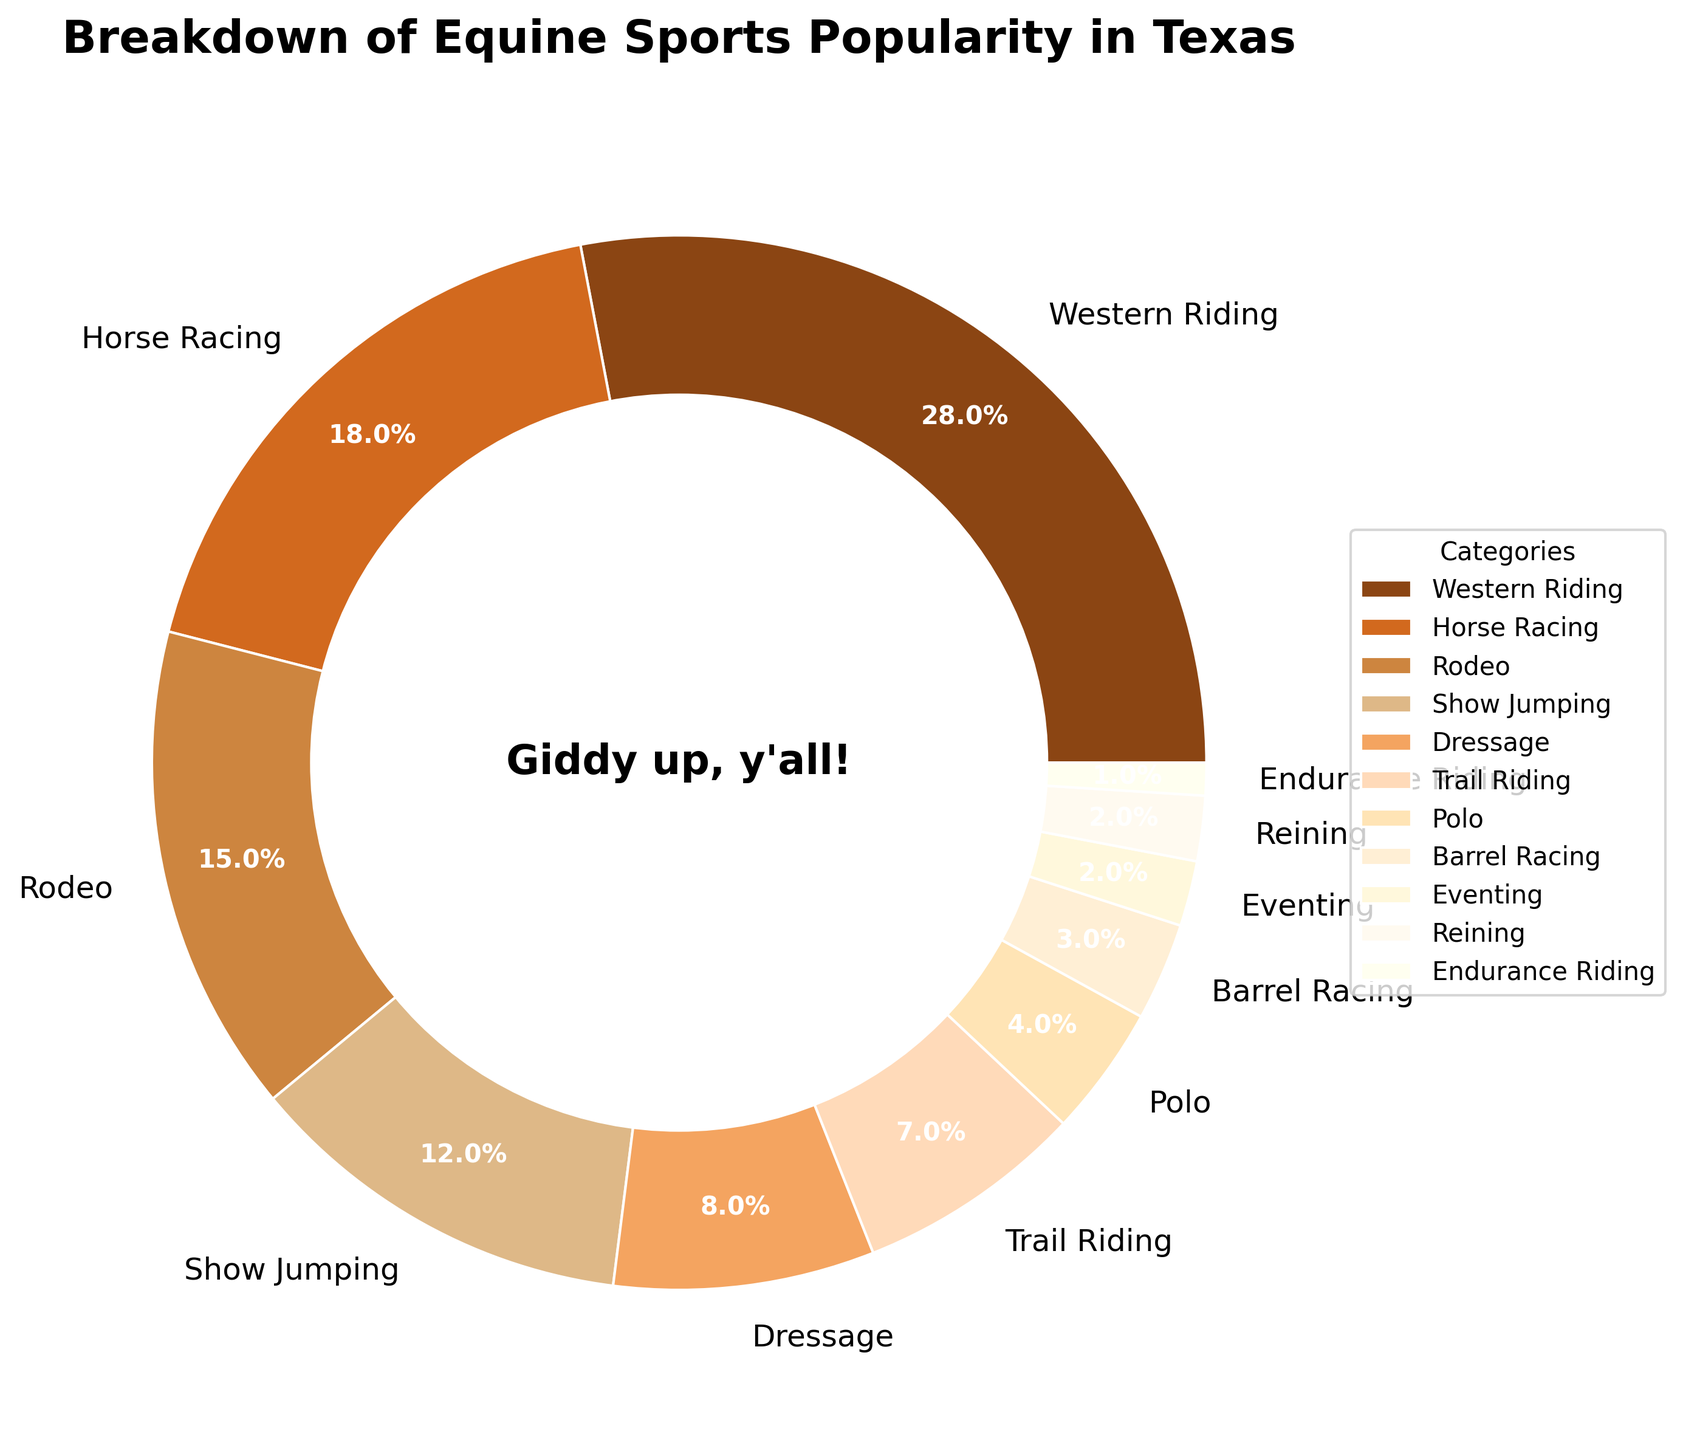What is the percentage of respondents who are interested in Western Riding? Western Riding takes up 28% of the pie chart.
Answer: 28% Which category is more popular, Rodeo or Show Jumping? Rodeo is represented by a larger segment in the pie chart with 15% compared to Show Jumping's 12%.
Answer: Rodeo What is the total percentage for Horse Racing, Dressage, and Trail Riding combined? Adding their percentages: Horse Racing (18%) + Dressage (8%) + Trail Riding (7%) = 18 + 8 + 7 = 33%.
Answer: 33% Which category has the smallest segment in the pie chart? Endurance Riding has the smallest segment in the chart, representing 1%.
Answer: Endurance Riding How much more popular is Western Riding than Barrel Racing? The difference in percentages is calculated as 28% (Western Riding) - 3% (Barrel Racing) = 25%.
Answer: 25% Are there more categories above or below 5% in the chart? Counting categories: Above 5% (six categories: Western Riding, Horse Racing, Rodeo, Show Jumping, Dressage, Trail Riding); Below 5% (five categories: Polo, Barrel Racing, Eventing, Reining, Endurance Riding). There are more categories above 5%.
Answer: Above 5% Which two categories have an equal percentage of popularity? Eventing and Reining both have a 2% share in the pie chart.
Answer: Eventing and Reining What is the percentage difference between the most and least popular categories? Western Riding is the most popular at 28%, and Endurance Riding is the least popular at 1%. Thus, the difference is 28% - 1% = 27%.
Answer: 27% What percentage of respondents are interested in equine sports other than Horse Racing? Subtract Horse Racing from 100%: 100% - 18% = 82%.
Answer: 82% 